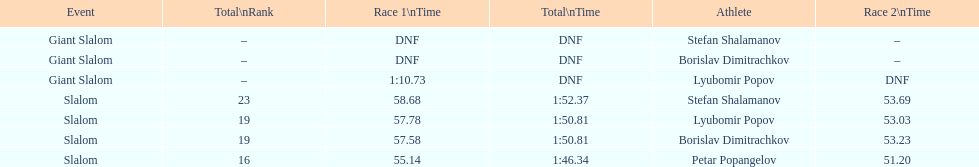What is the rank number of stefan shalamanov in the slalom event 23. Parse the full table. {'header': ['Event', 'Total\\nRank', 'Race 1\\nTime', 'Total\\nTime', 'Athlete', 'Race 2\\nTime'], 'rows': [['Giant Slalom', '–', 'DNF', 'DNF', 'Stefan Shalamanov', '–'], ['Giant Slalom', '–', 'DNF', 'DNF', 'Borislav Dimitrachkov', '–'], ['Giant Slalom', '–', '1:10.73', 'DNF', 'Lyubomir Popov', 'DNF'], ['Slalom', '23', '58.68', '1:52.37', 'Stefan Shalamanov', '53.69'], ['Slalom', '19', '57.78', '1:50.81', 'Lyubomir Popov', '53.03'], ['Slalom', '19', '57.58', '1:50.81', 'Borislav Dimitrachkov', '53.23'], ['Slalom', '16', '55.14', '1:46.34', 'Petar Popangelov', '51.20']]} 